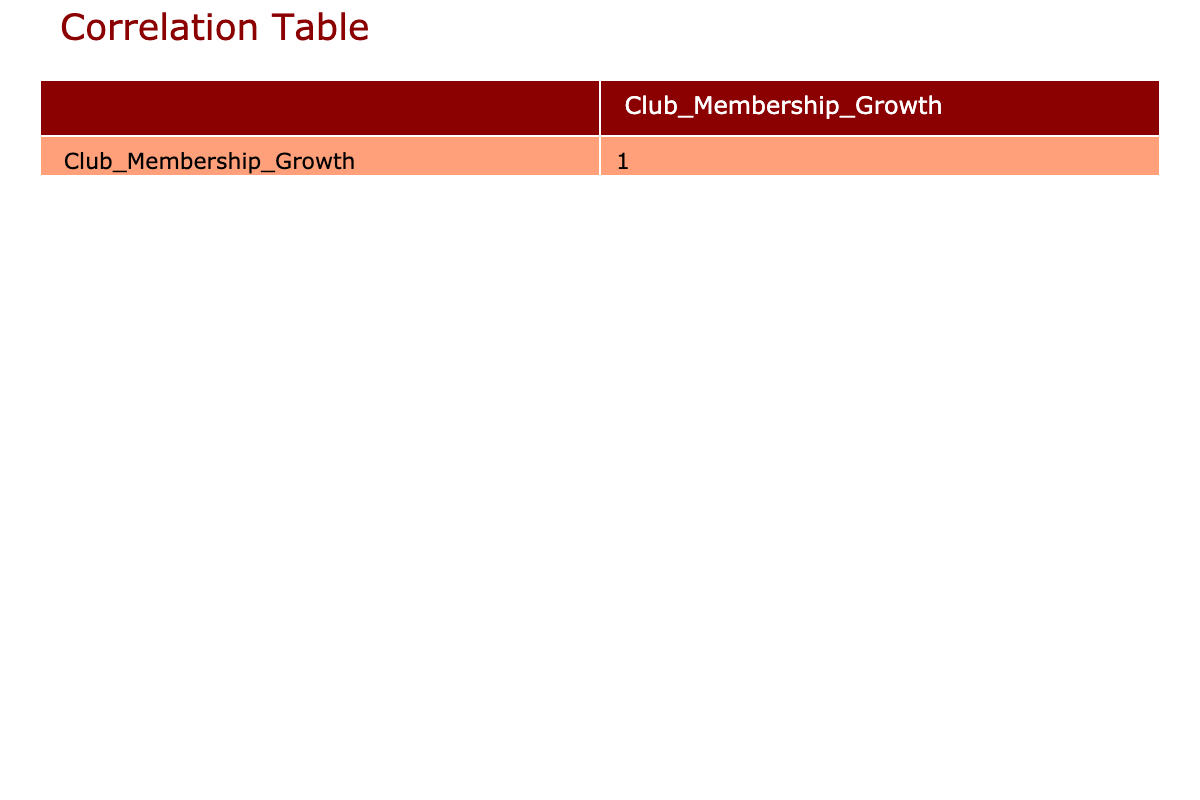What is the highest club membership growth recorded? The table indicates that the highest club membership growth is associated with the Health Screening outreach effort, which stands at 30.
Answer: 30 Which community outreach effort has the lowest membership growth? According to the table, the Trivia Night Fundraiser has the lowest membership growth, recorded at 5.
Answer: 5 What is the average club membership growth for all outreach efforts? To find the average, we sum all membership growth values: (15 + 25 + 10 + 30 + 20 + 18 + 22 + 5 + 14 + 28) =  18.2, and divide by the number of outreach efforts (10), resulting in an average club membership growth of 18.2.
Answer: 18.2 Is there a positive correlation between community outreach efforts and club membership growth? Observing the correlation value in the table, it is likely above zero, indicating a positive correlation, meaning as outreach efforts increase, so does membership growth.
Answer: Yes Which outreach effort resulted in a growth that is more than half of the maximum growth recorded? The maximum growth recorded is 30, so half would be 15. The following outreach efforts exceeded this: Youth Sports Clinic (25), Health Screening (30), Pet Adoption Event (28), and Mental Health Workshops (22).
Answer: Youth Sports Clinic, Health Screening, Pet Adoption Event, Mental Health Workshops What is the difference in membership growth between the highest and the lowest performing outreach efforts? The highest membership growth is 30 (Health Screening) and the lowest is 5 (Trivia Night Fundraiser). Therefore, the difference is 30 - 5 = 25.
Answer: 25 Which two outreach efforts combined result in a club membership growth of 55? By examining the growth values, Food Drive (15) and Pet Adoption Event (28) combine to 15 + 28 = 43, and others fail to reach 55. Therefore, no two efforts sum to 55.
Answer: No How many outreach efforts had a membership growth greater than or equal to 20? Reviewing the table, we find the Community Clean Up (20), Health Screening (30), Pet Adoption Event (28), Youth Sports Clinic (25), and Mental Health Workshops (22), totaling five efforts meeting or exceeding 20 in growth.
Answer: 5 